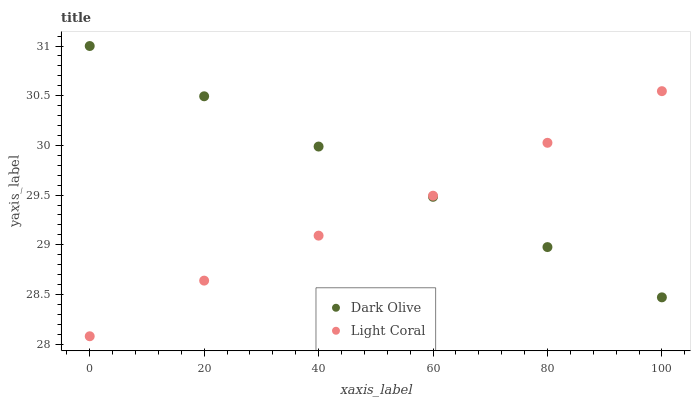Does Light Coral have the minimum area under the curve?
Answer yes or no. Yes. Does Dark Olive have the maximum area under the curve?
Answer yes or no. Yes. Does Dark Olive have the minimum area under the curve?
Answer yes or no. No. Is Dark Olive the smoothest?
Answer yes or no. Yes. Is Light Coral the roughest?
Answer yes or no. Yes. Is Dark Olive the roughest?
Answer yes or no. No. Does Light Coral have the lowest value?
Answer yes or no. Yes. Does Dark Olive have the lowest value?
Answer yes or no. No. Does Dark Olive have the highest value?
Answer yes or no. Yes. Does Light Coral intersect Dark Olive?
Answer yes or no. Yes. Is Light Coral less than Dark Olive?
Answer yes or no. No. Is Light Coral greater than Dark Olive?
Answer yes or no. No. 